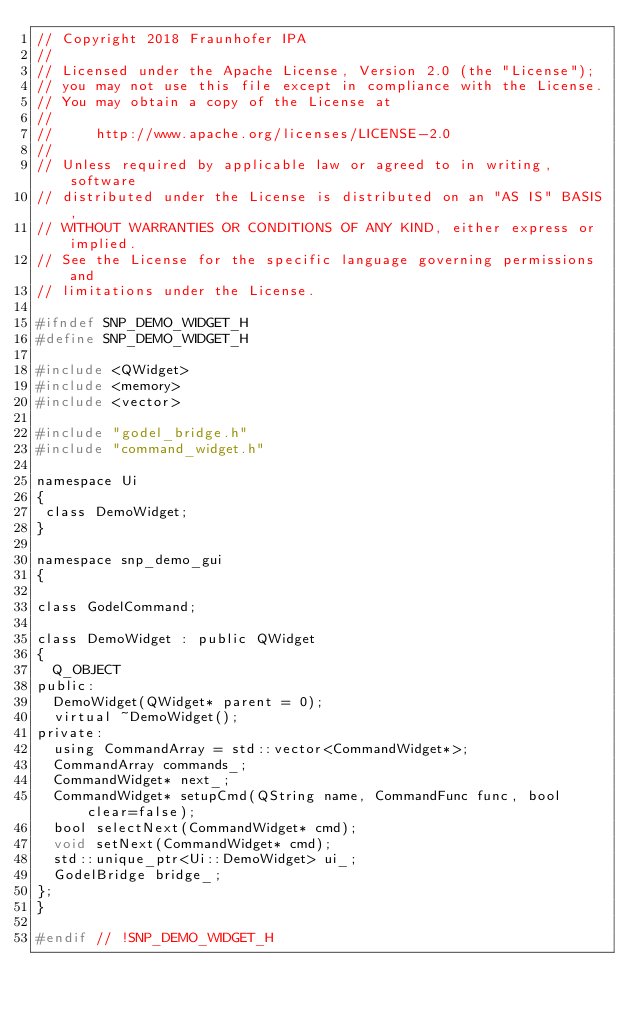Convert code to text. <code><loc_0><loc_0><loc_500><loc_500><_C_>// Copyright 2018 Fraunhofer IPA
//
// Licensed under the Apache License, Version 2.0 (the "License");
// you may not use this file except in compliance with the License.
// You may obtain a copy of the License at
//
//     http://www.apache.org/licenses/LICENSE-2.0
//
// Unless required by applicable law or agreed to in writing, software
// distributed under the License is distributed on an "AS IS" BASIS,
// WITHOUT WARRANTIES OR CONDITIONS OF ANY KIND, either express or implied.
// See the License for the specific language governing permissions and
// limitations under the License.

#ifndef SNP_DEMO_WIDGET_H
#define SNP_DEMO_WIDGET_H

#include <QWidget>
#include <memory>
#include <vector>

#include "godel_bridge.h"
#include "command_widget.h"

namespace Ui
{
 class DemoWidget;
}

namespace snp_demo_gui
{

class GodelCommand;

class DemoWidget : public QWidget
{
  Q_OBJECT
public:
  DemoWidget(QWidget* parent = 0);
  virtual ~DemoWidget();
private:
  using CommandArray = std::vector<CommandWidget*>;
  CommandArray commands_;
  CommandWidget* next_;
  CommandWidget* setupCmd(QString name, CommandFunc func, bool clear=false);
  bool selectNext(CommandWidget* cmd);
  void setNext(CommandWidget* cmd);
  std::unique_ptr<Ui::DemoWidget> ui_;
  GodelBridge bridge_;
};
}

#endif // !SNP_DEMO_WIDGET_H
</code> 